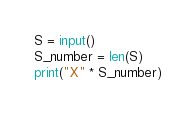<code> <loc_0><loc_0><loc_500><loc_500><_Python_>S = input()
S_number = len(S)
print("X" * S_number)</code> 